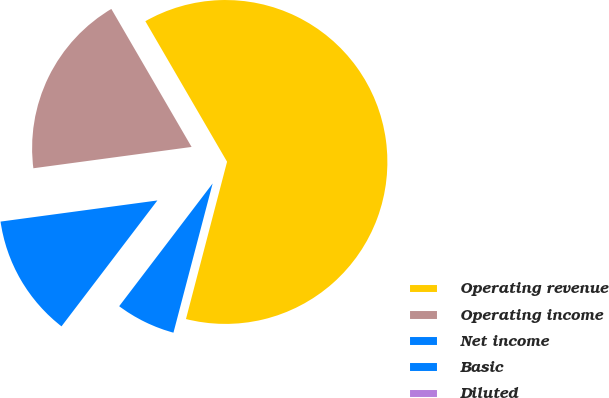Convert chart to OTSL. <chart><loc_0><loc_0><loc_500><loc_500><pie_chart><fcel>Operating revenue<fcel>Operating income<fcel>Net income<fcel>Basic<fcel>Diluted<nl><fcel>62.45%<fcel>18.75%<fcel>12.51%<fcel>6.27%<fcel>0.02%<nl></chart> 